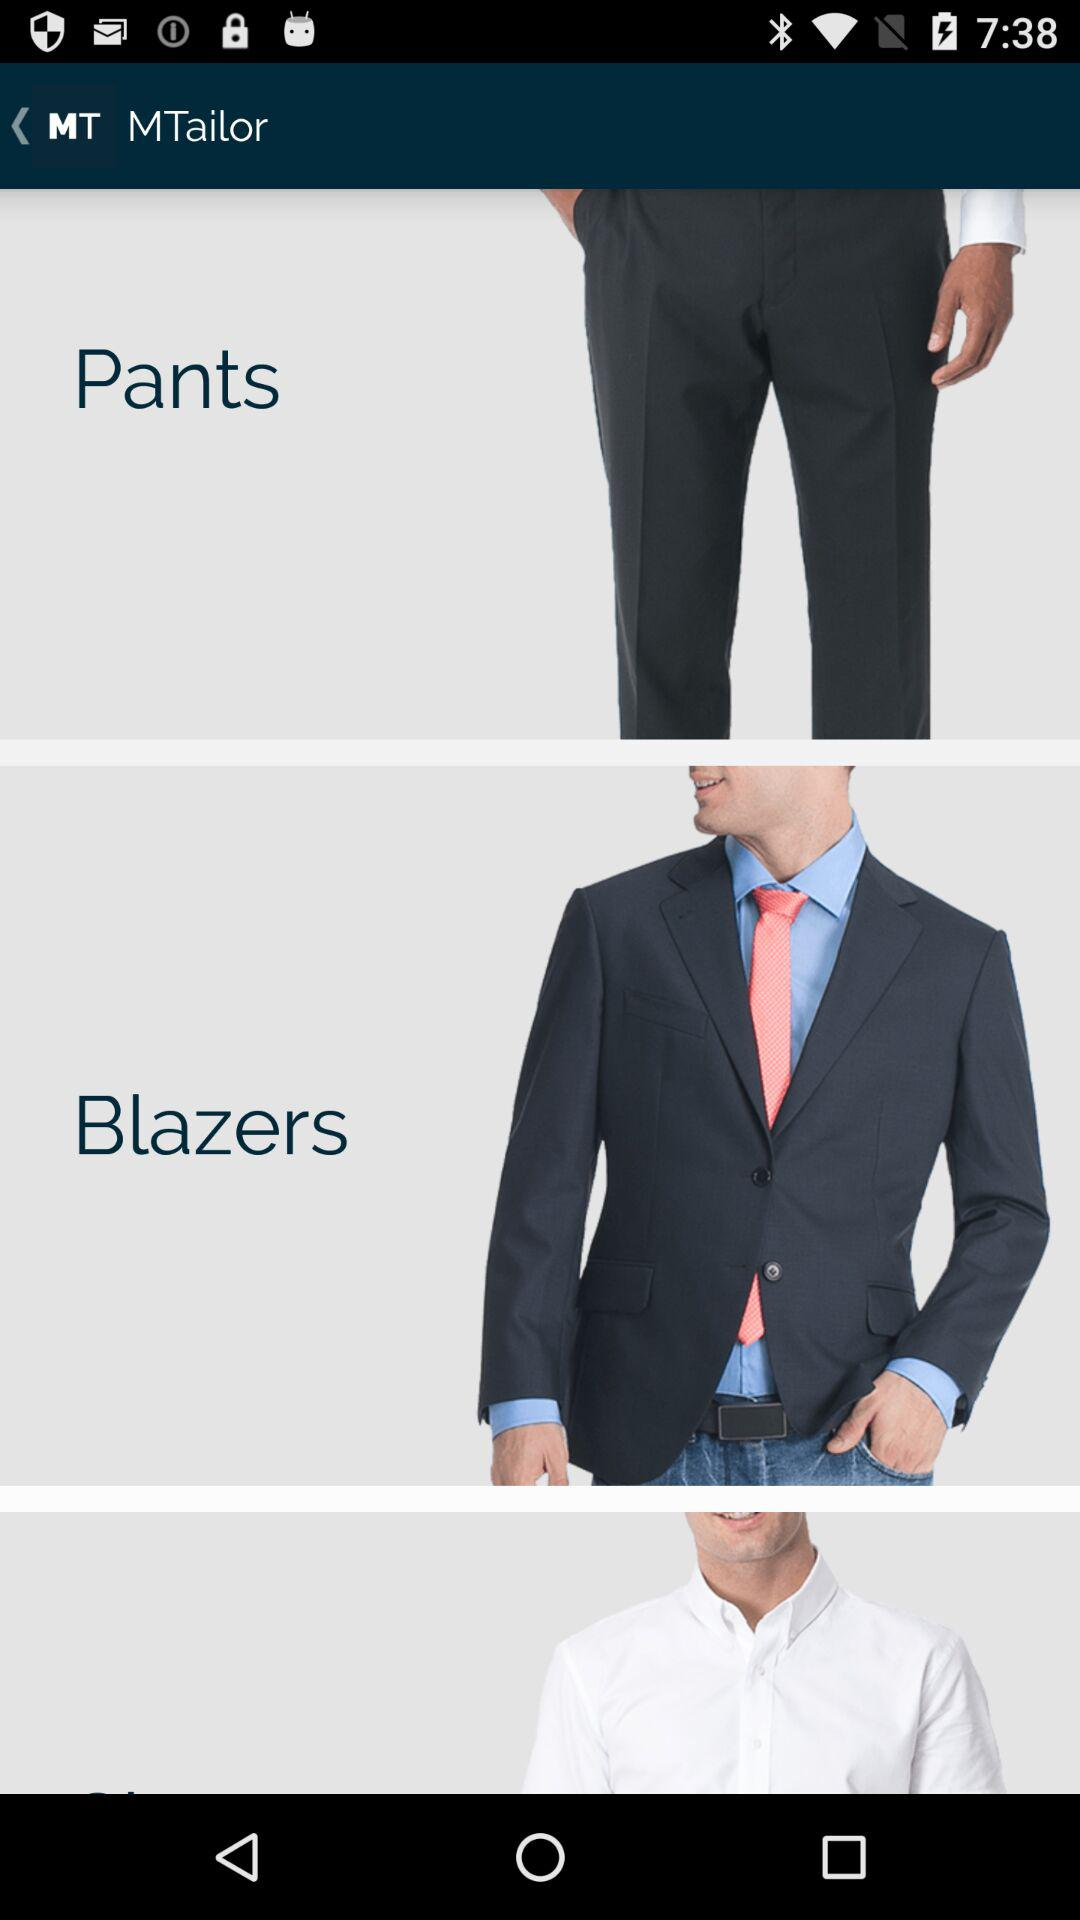What is the name of the application? The name of the application is "MTailor". 